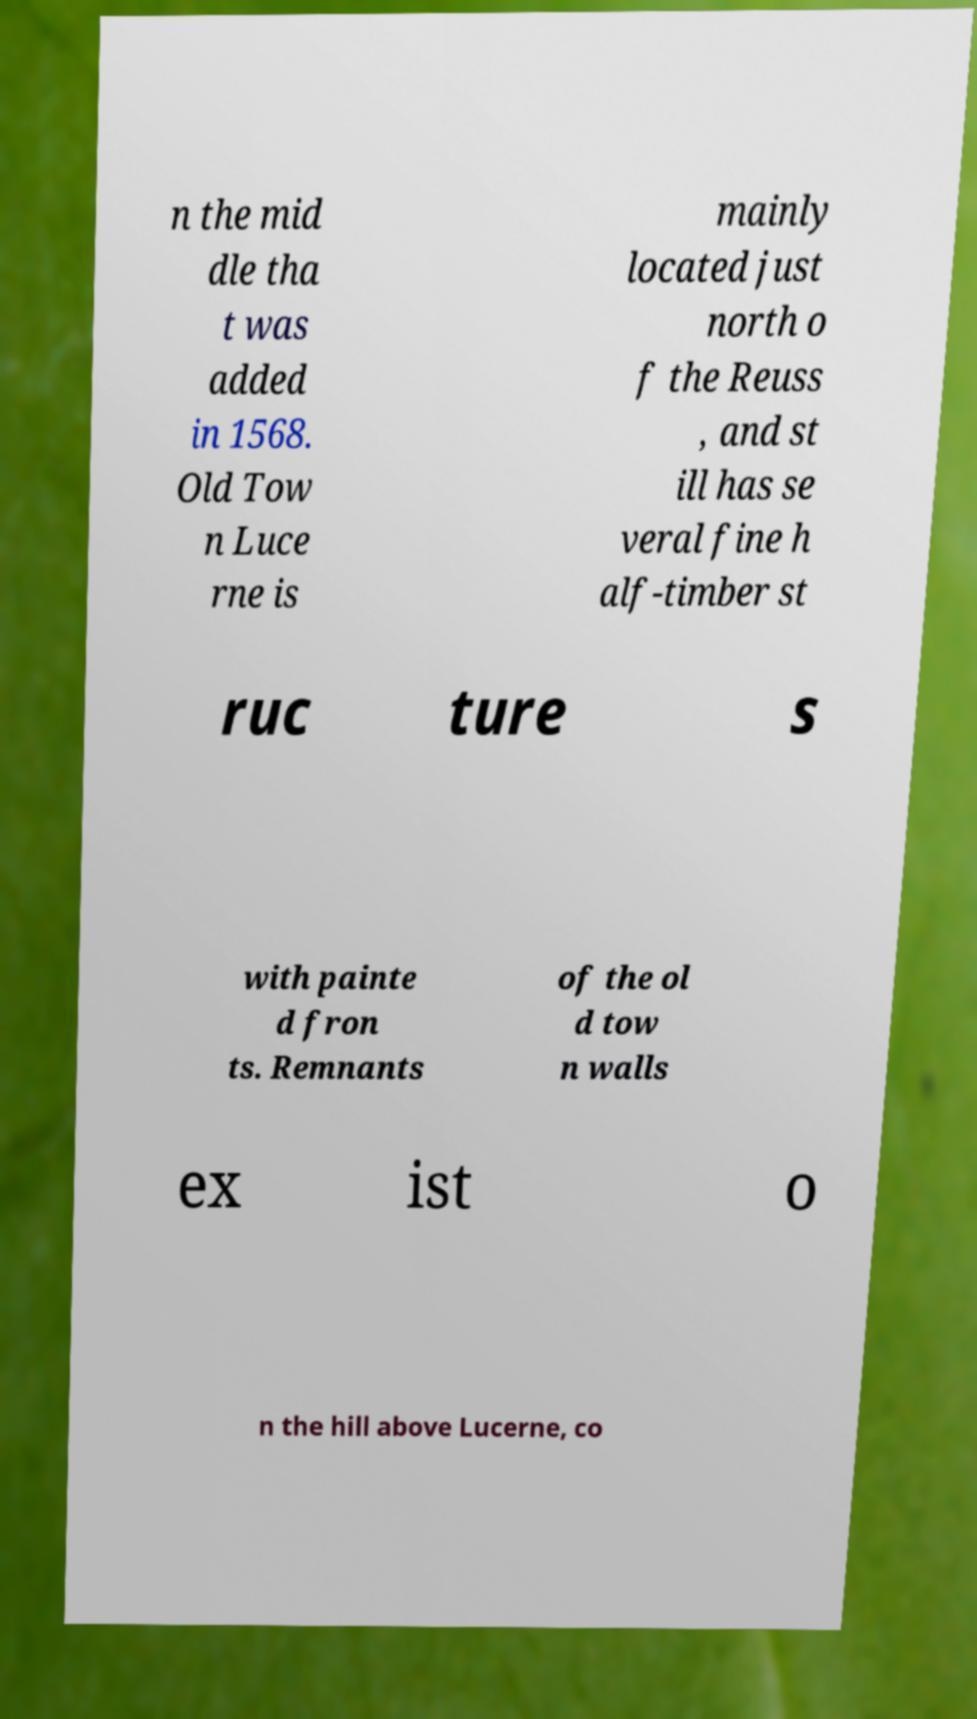What messages or text are displayed in this image? I need them in a readable, typed format. n the mid dle tha t was added in 1568. Old Tow n Luce rne is mainly located just north o f the Reuss , and st ill has se veral fine h alf-timber st ruc ture s with painte d fron ts. Remnants of the ol d tow n walls ex ist o n the hill above Lucerne, co 